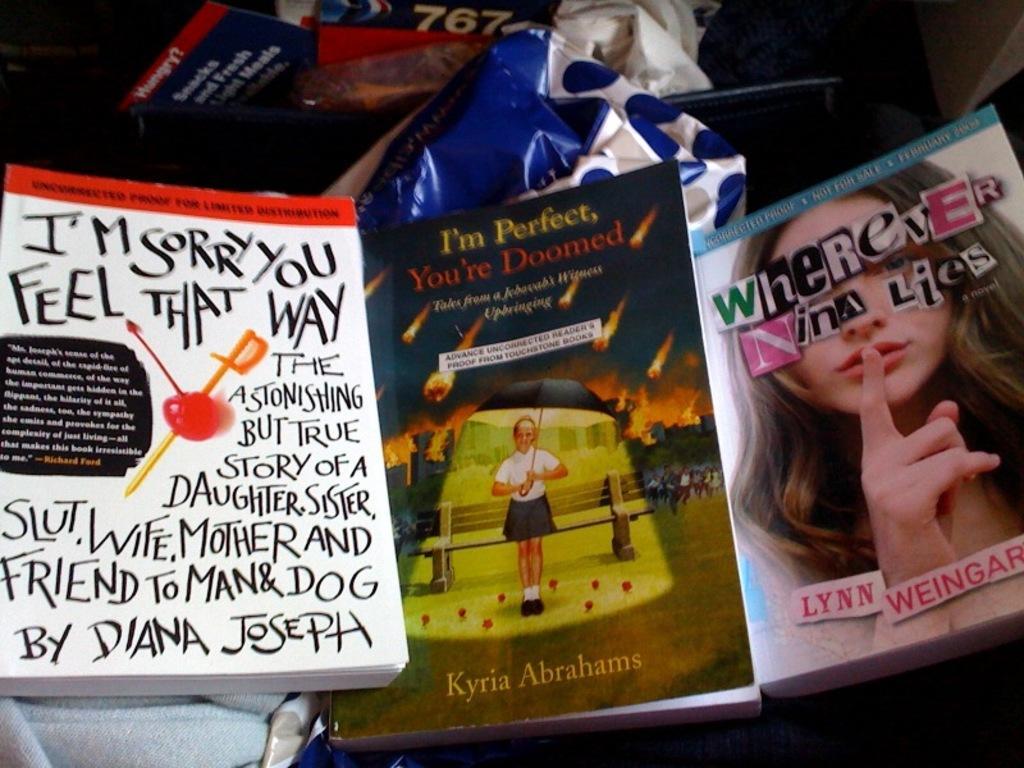Describe this image in one or two sentences. In this image, we can see few books, some objects and clothes. Here we can see some text, numerical numbers and pictures on the books. 